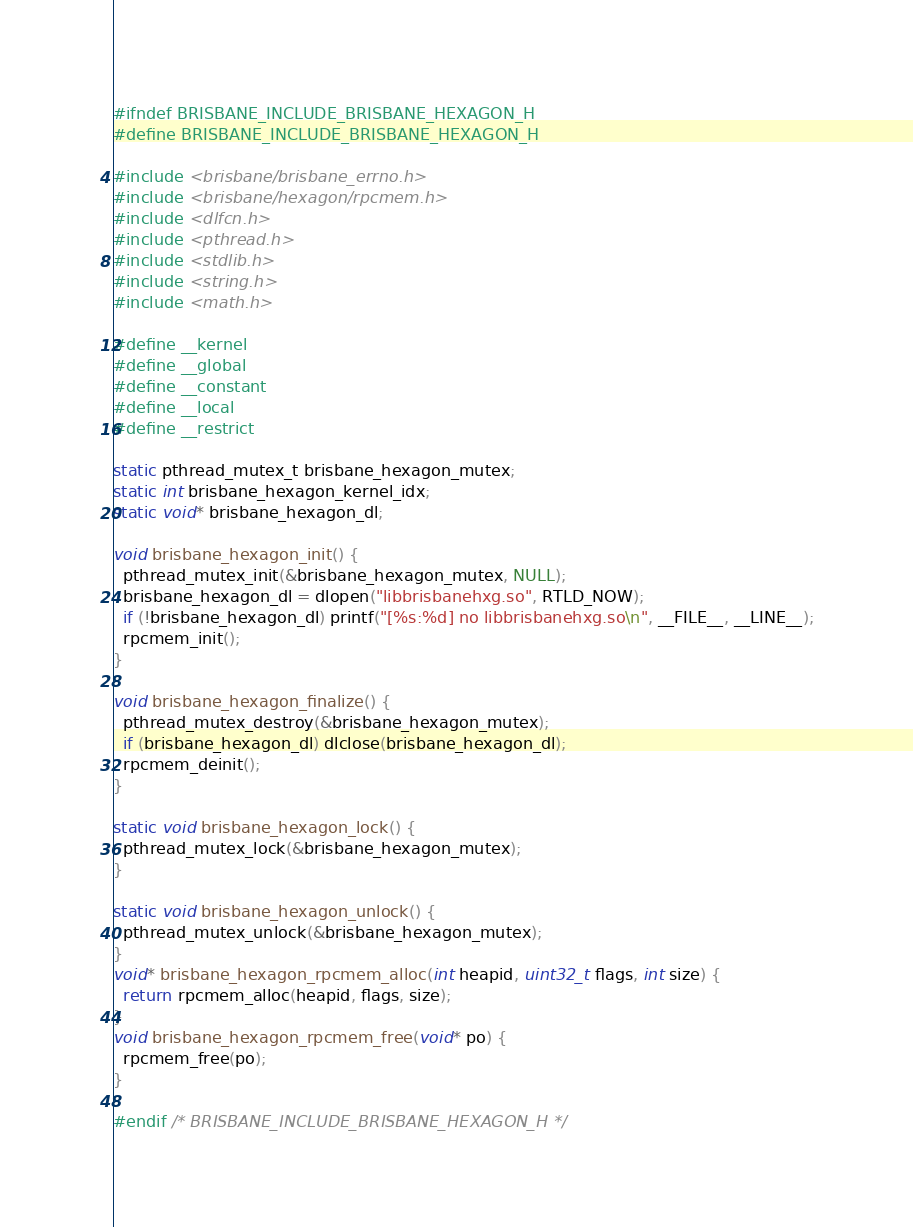Convert code to text. <code><loc_0><loc_0><loc_500><loc_500><_C_>#ifndef BRISBANE_INCLUDE_BRISBANE_HEXAGON_H
#define BRISBANE_INCLUDE_BRISBANE_HEXAGON_H

#include <brisbane/brisbane_errno.h>
#include <brisbane/hexagon/rpcmem.h>
#include <dlfcn.h>
#include <pthread.h>
#include <stdlib.h>
#include <string.h>
#include <math.h>

#define __kernel
#define __global
#define __constant
#define __local
#define __restrict

static pthread_mutex_t brisbane_hexagon_mutex;
static int brisbane_hexagon_kernel_idx;
static void* brisbane_hexagon_dl;

void brisbane_hexagon_init() {
  pthread_mutex_init(&brisbane_hexagon_mutex, NULL);
  brisbane_hexagon_dl = dlopen("libbrisbanehxg.so", RTLD_NOW);
  if (!brisbane_hexagon_dl) printf("[%s:%d] no libbrisbanehxg.so\n", __FILE__, __LINE__);
  rpcmem_init();
}

void brisbane_hexagon_finalize() {
  pthread_mutex_destroy(&brisbane_hexagon_mutex);
  if (brisbane_hexagon_dl) dlclose(brisbane_hexagon_dl);
  rpcmem_deinit();
}

static void brisbane_hexagon_lock() {
  pthread_mutex_lock(&brisbane_hexagon_mutex);
}

static void brisbane_hexagon_unlock() {
  pthread_mutex_unlock(&brisbane_hexagon_mutex);
}
void* brisbane_hexagon_rpcmem_alloc(int heapid, uint32_t flags, int size) {
  return rpcmem_alloc(heapid, flags, size);
}
void brisbane_hexagon_rpcmem_free(void* po) {
  rpcmem_free(po);
}

#endif /* BRISBANE_INCLUDE_BRISBANE_HEXAGON_H */

</code> 